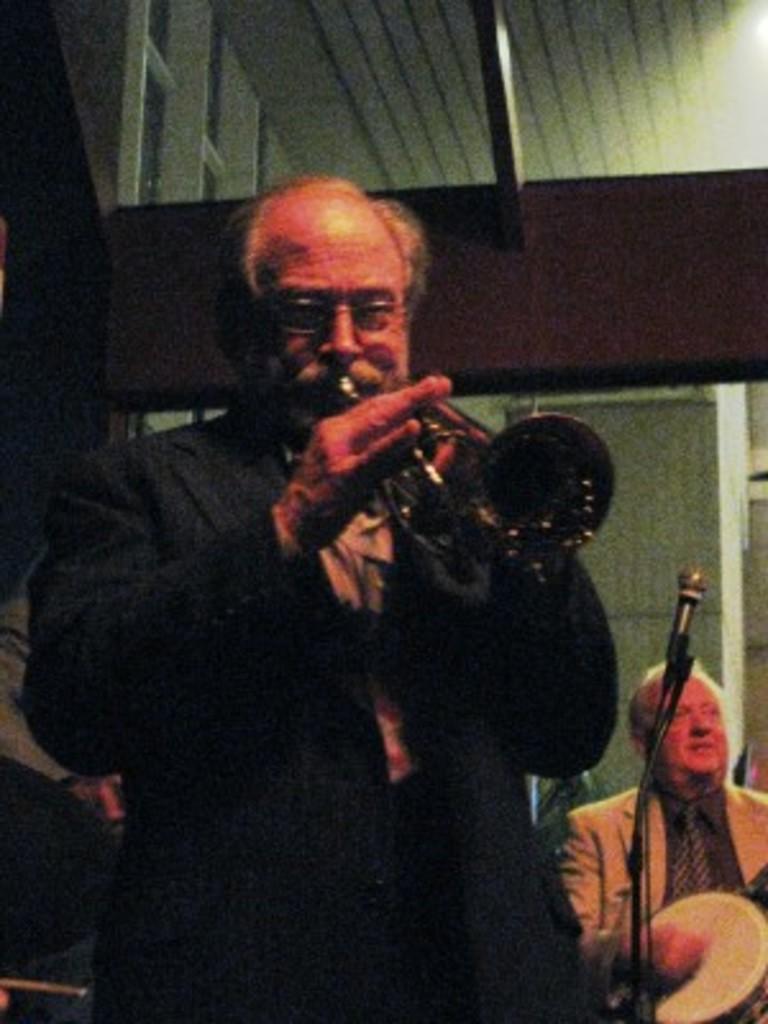Describe this image in one or two sentences. In this image there is a man standing. He is playing a musical instrument. Beside him there is a microphone. Behind the microphone there's a man sitting. In the background there is a wall. At the top there is a ceiling. 